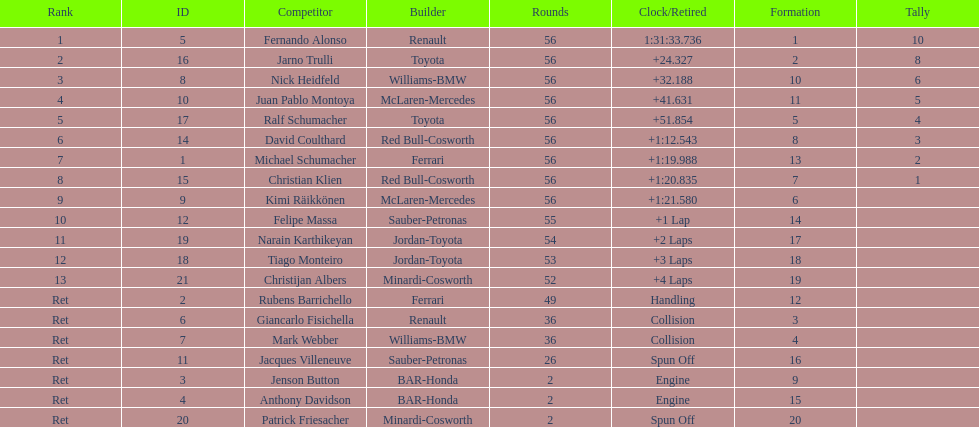Who finished before nick heidfeld? Jarno Trulli. 